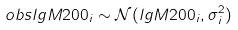<formula> <loc_0><loc_0><loc_500><loc_500>o b s l g M 2 0 0 _ { i } \sim \mathcal { N } ( l g M 2 0 0 _ { i } , \sigma ^ { 2 } _ { i } )</formula> 